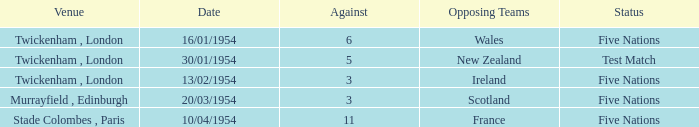What is the status when the against is 11? Five Nations. 